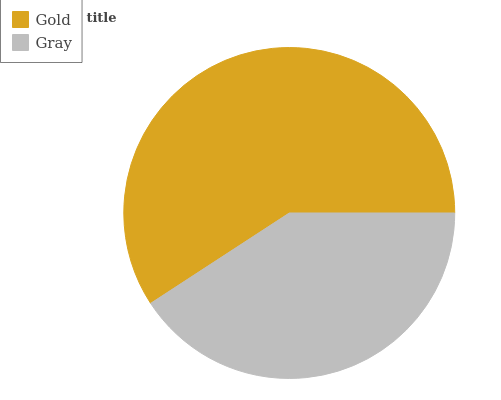Is Gray the minimum?
Answer yes or no. Yes. Is Gold the maximum?
Answer yes or no. Yes. Is Gray the maximum?
Answer yes or no. No. Is Gold greater than Gray?
Answer yes or no. Yes. Is Gray less than Gold?
Answer yes or no. Yes. Is Gray greater than Gold?
Answer yes or no. No. Is Gold less than Gray?
Answer yes or no. No. Is Gold the high median?
Answer yes or no. Yes. Is Gray the low median?
Answer yes or no. Yes. Is Gray the high median?
Answer yes or no. No. Is Gold the low median?
Answer yes or no. No. 